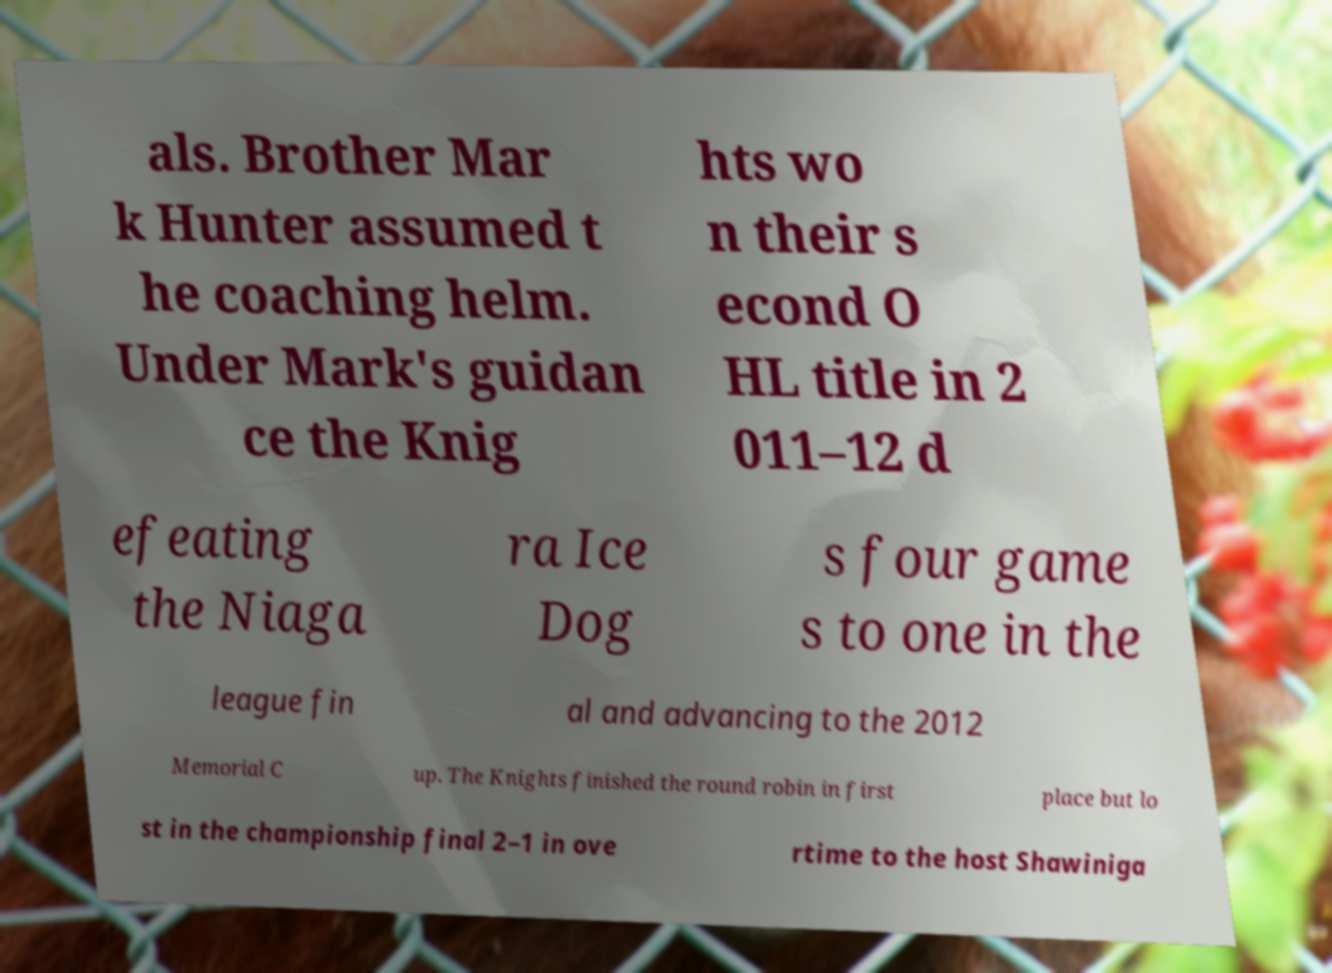Please identify and transcribe the text found in this image. als. Brother Mar k Hunter assumed t he coaching helm. Under Mark's guidan ce the Knig hts wo n their s econd O HL title in 2 011–12 d efeating the Niaga ra Ice Dog s four game s to one in the league fin al and advancing to the 2012 Memorial C up. The Knights finished the round robin in first place but lo st in the championship final 2–1 in ove rtime to the host Shawiniga 